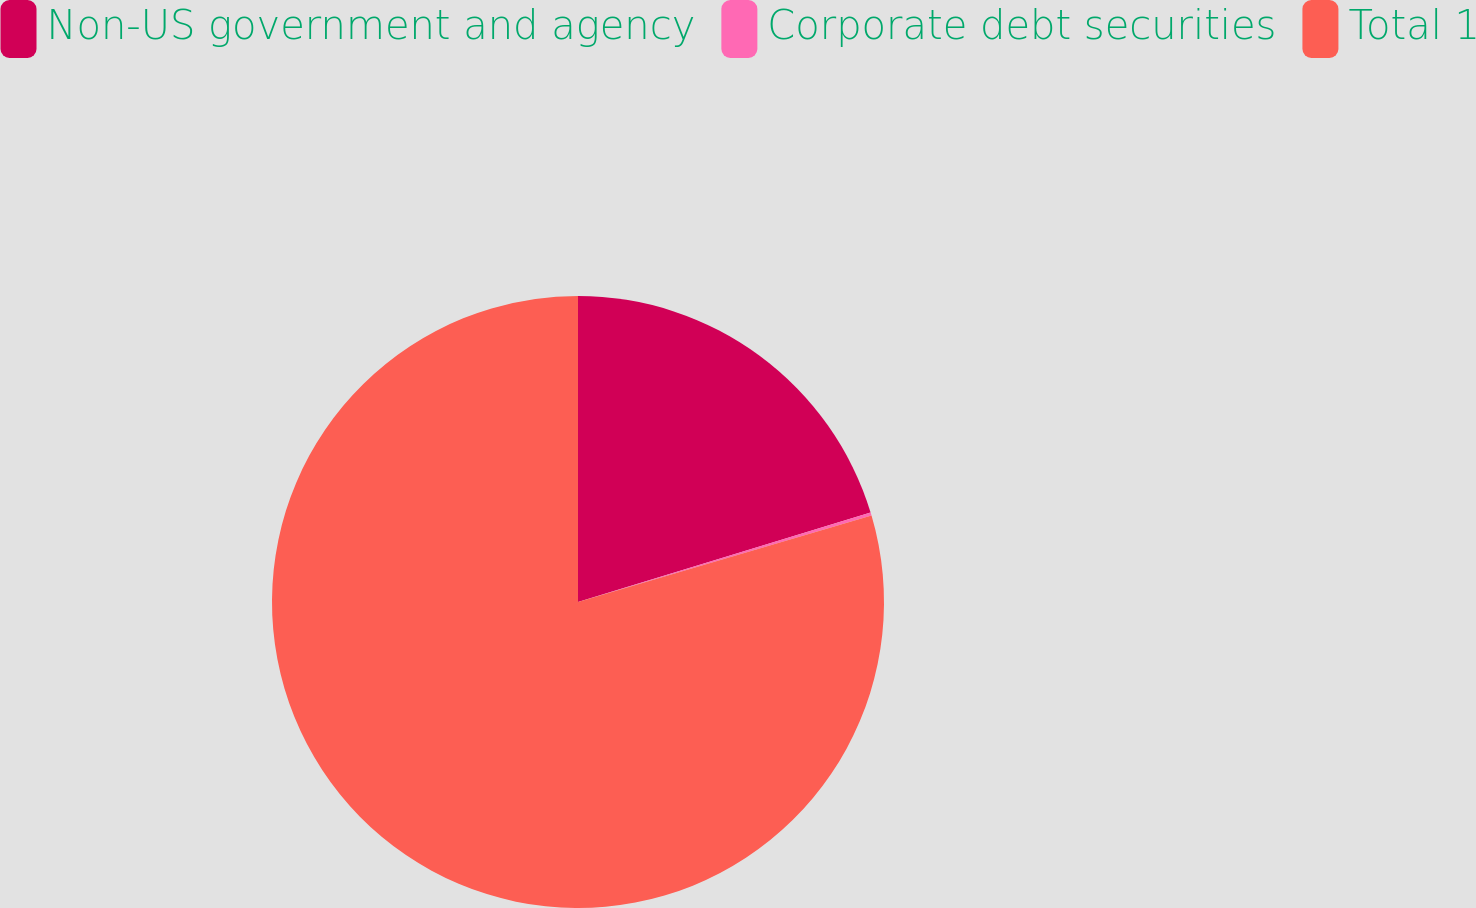Convert chart. <chart><loc_0><loc_0><loc_500><loc_500><pie_chart><fcel>Non-US government and agency<fcel>Corporate debt securities<fcel>Total 1<nl><fcel>20.27%<fcel>0.17%<fcel>79.56%<nl></chart> 